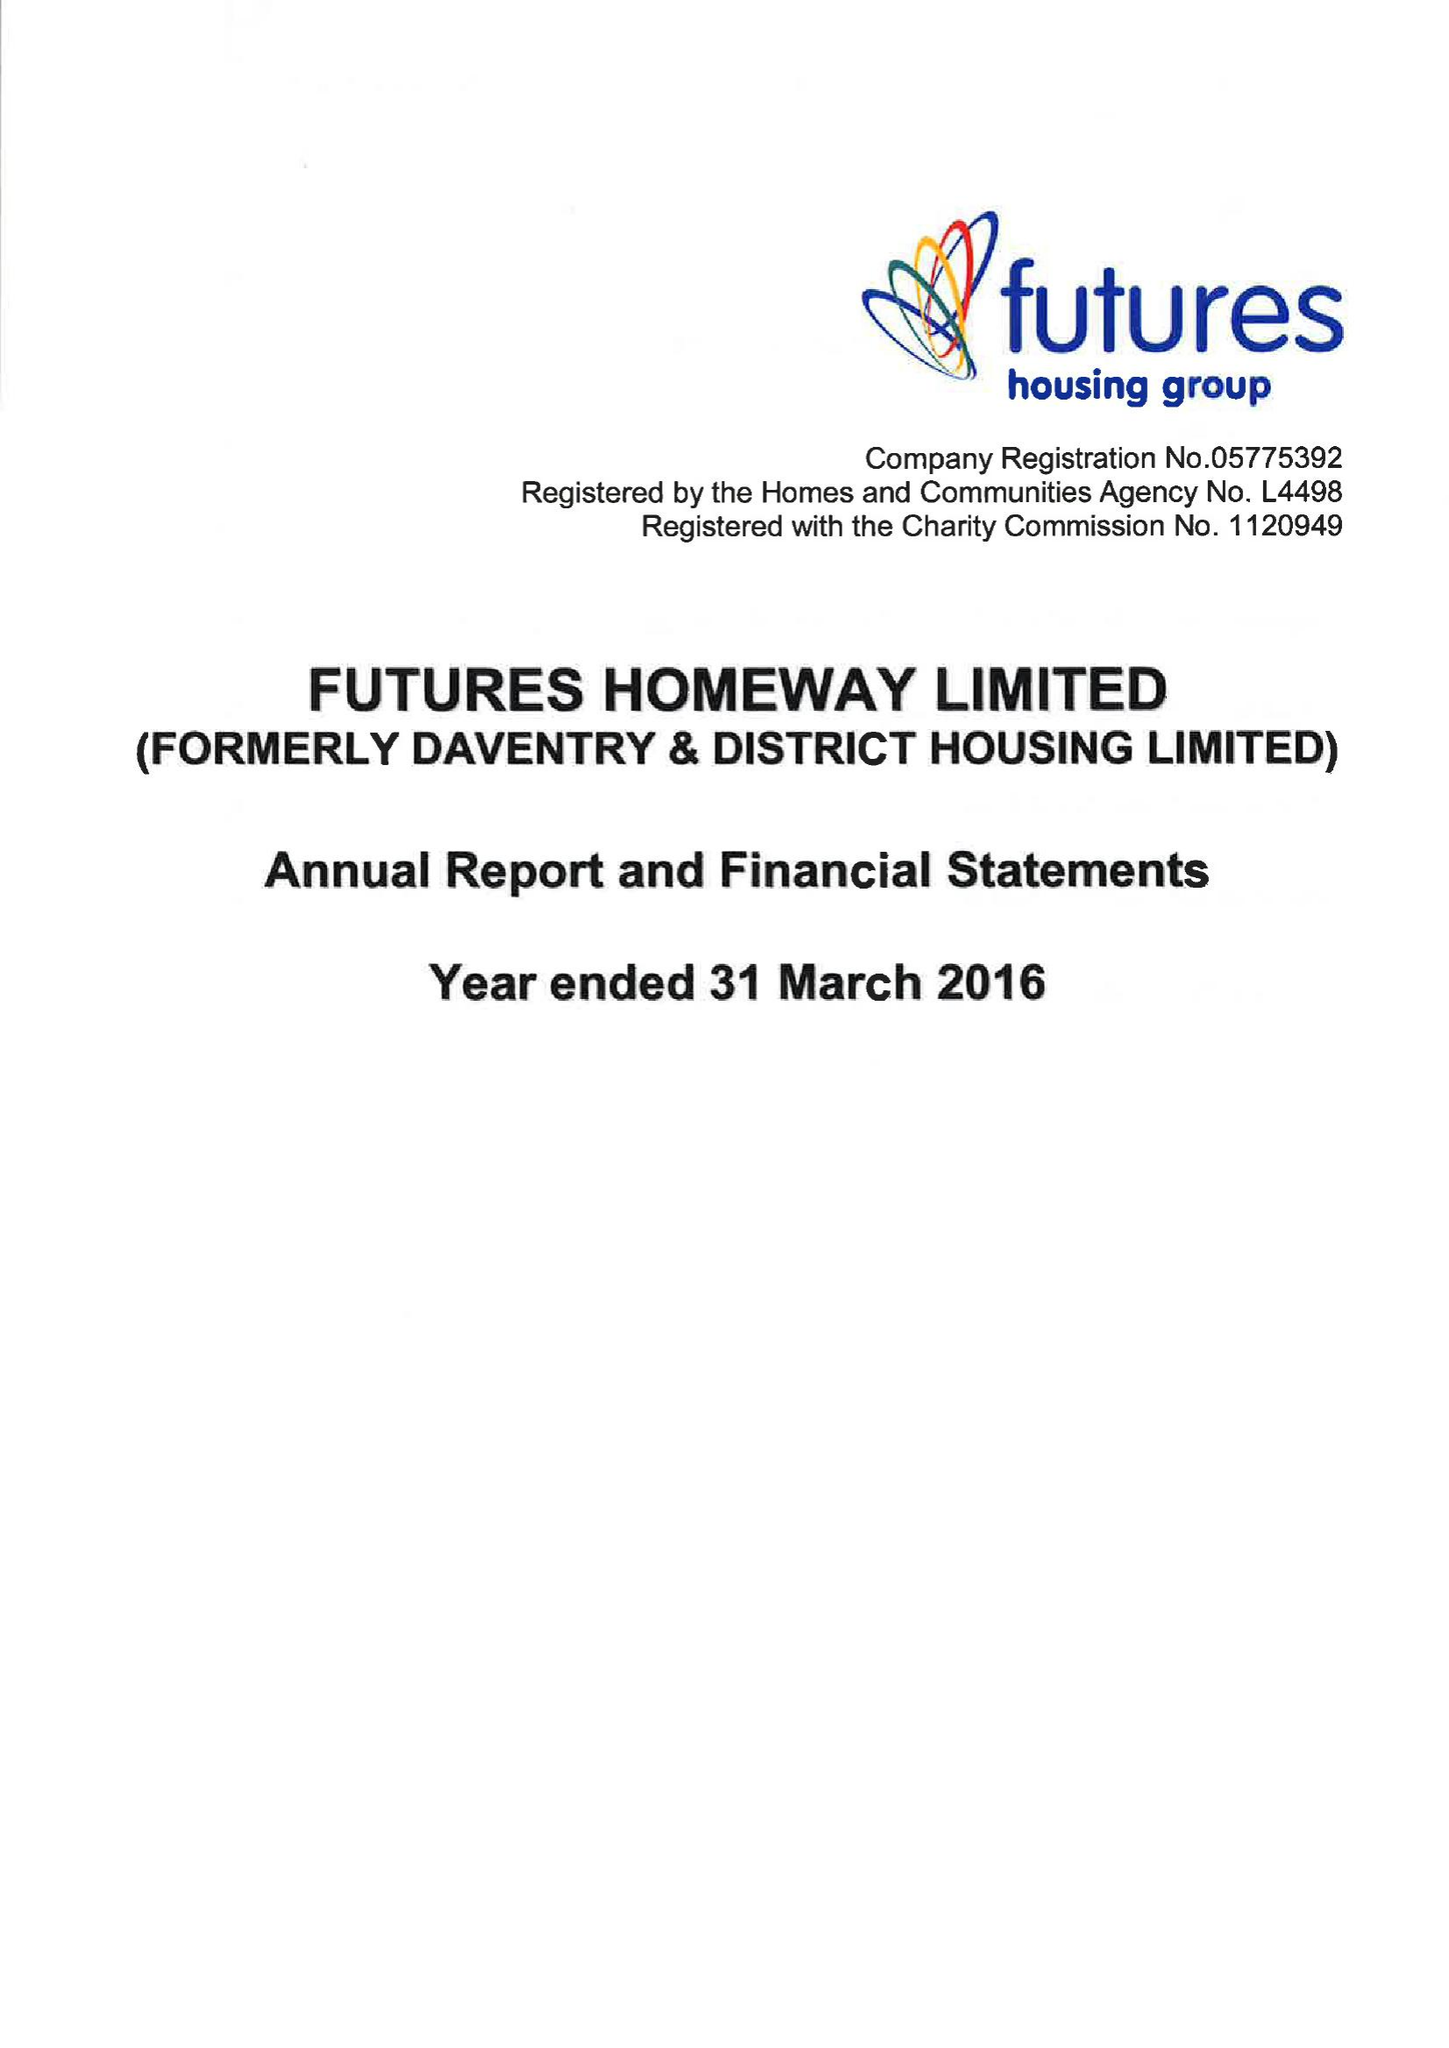What is the value for the address__post_town?
Answer the question using a single word or phrase. RIPLEY 